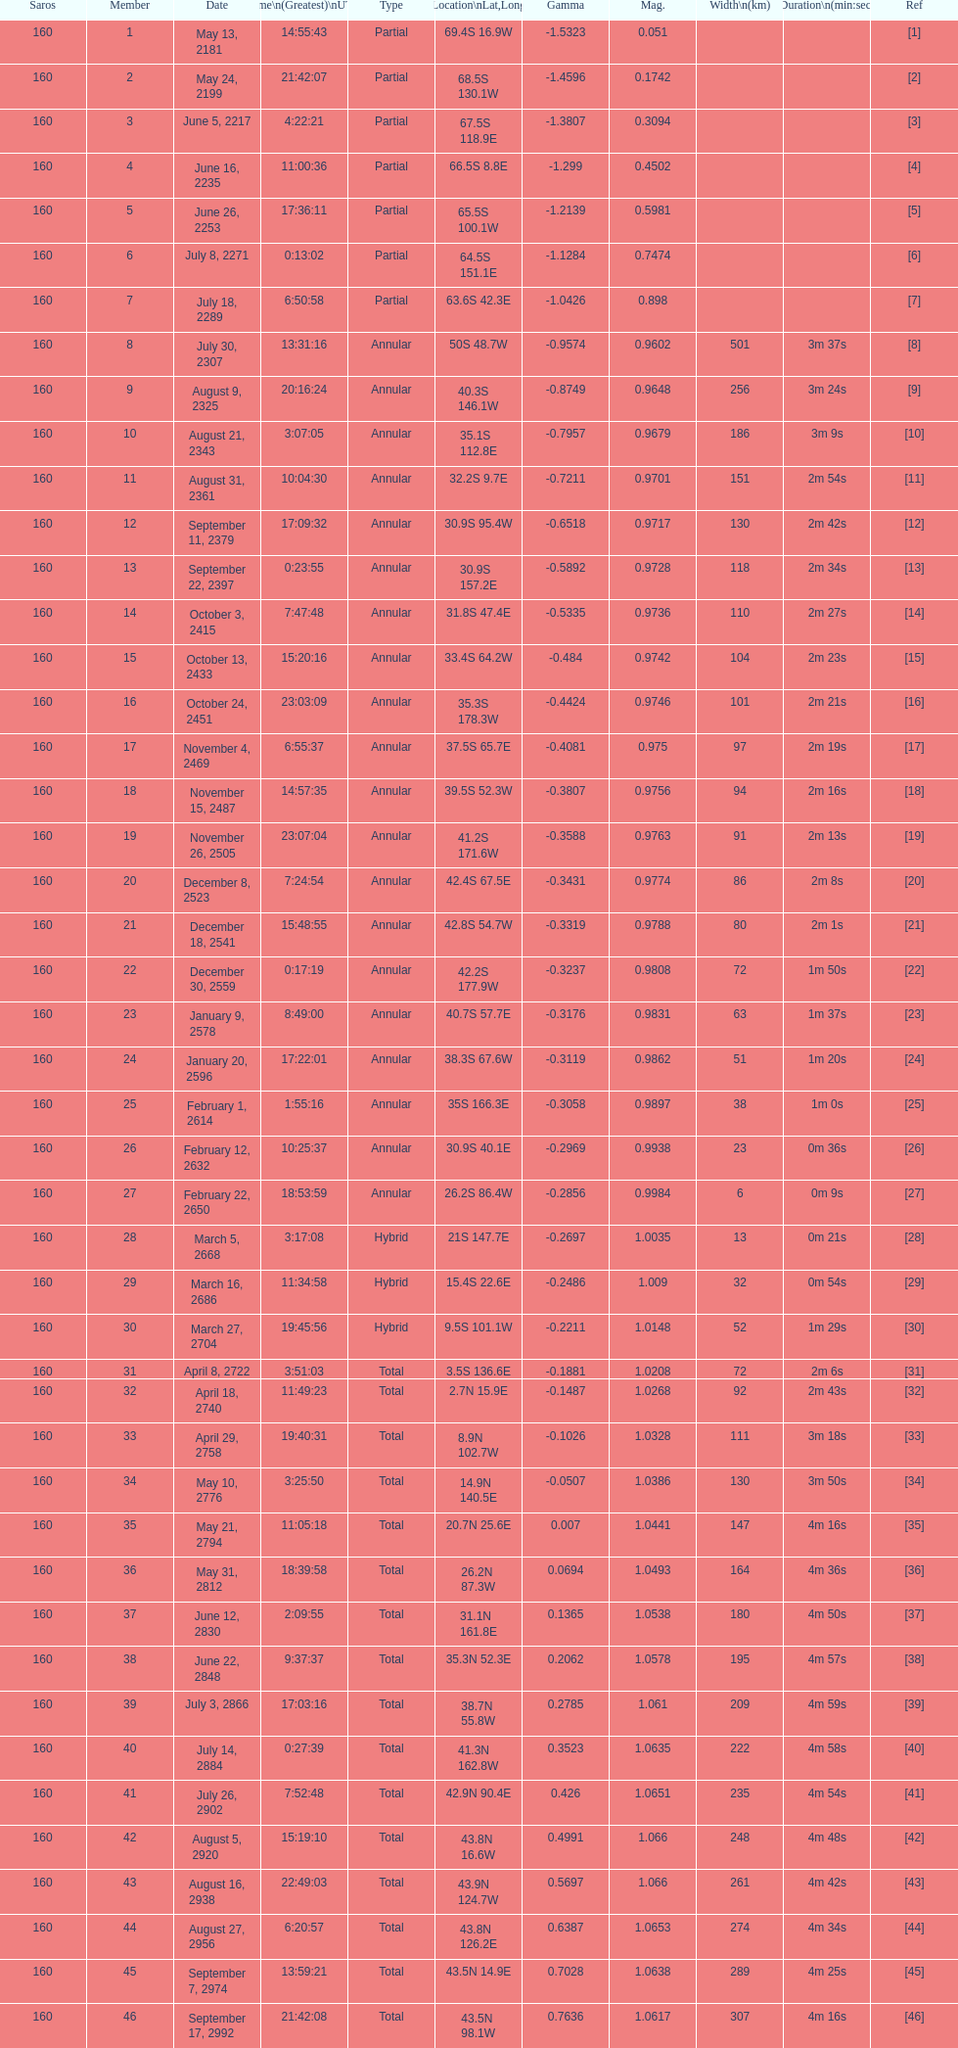00 observed? March 5, 2668. 